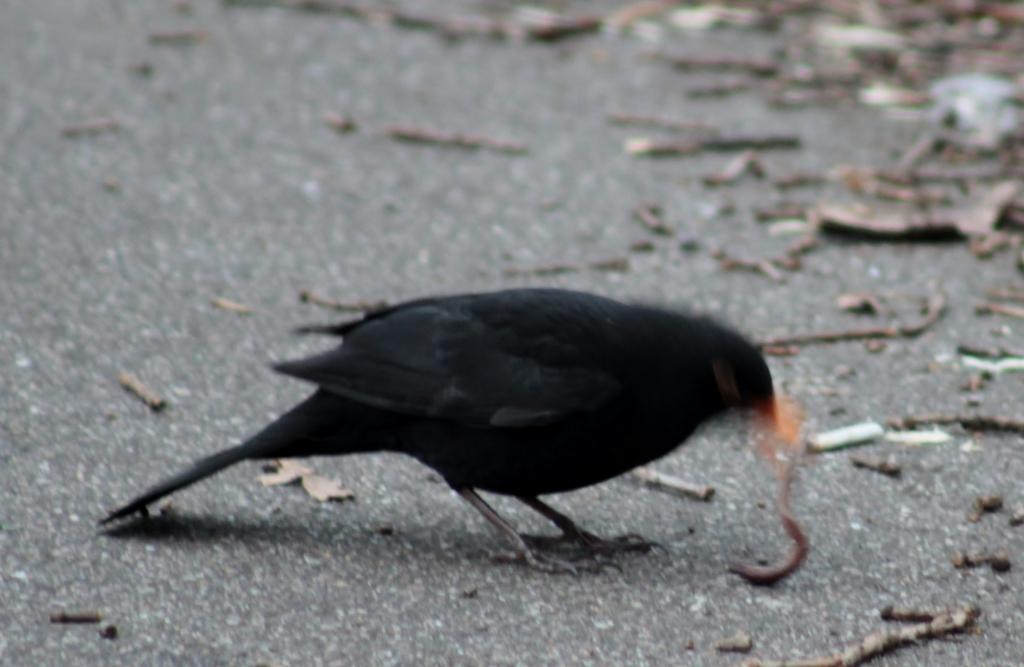What type of animal can be seen in the image? There is a bird in the image. What can be found on the ground in the image? There are objects on the ground in the image. What type of brick is the bird using to build its nest in the image? There is no brick present in the image, nor is there any indication that the bird is building a nest. 